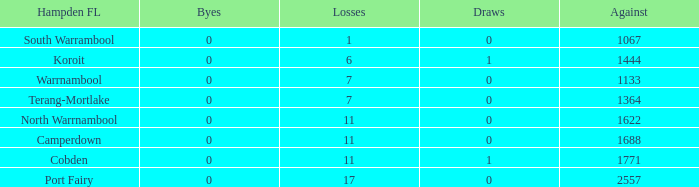What were the losses when the byes were below zero? None. 